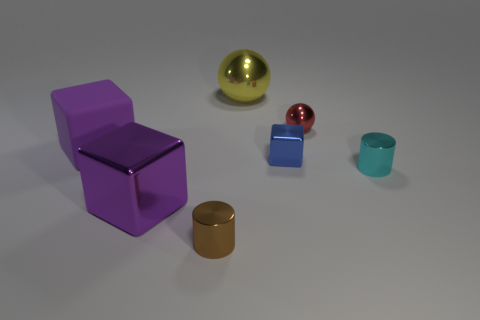Subtract all big purple metallic blocks. How many blocks are left? 2 Add 2 metal objects. How many objects exist? 9 Subtract all brown cylinders. How many cylinders are left? 1 Subtract all balls. How many objects are left? 5 Subtract 1 blocks. How many blocks are left? 2 Subtract all green cylinders. Subtract all green cubes. How many cylinders are left? 2 Subtract all purple balls. How many purple blocks are left? 2 Subtract all large green blocks. Subtract all yellow balls. How many objects are left? 6 Add 1 tiny brown metallic cylinders. How many tiny brown metallic cylinders are left? 2 Add 6 large green cubes. How many large green cubes exist? 6 